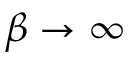Convert formula to latex. <formula><loc_0><loc_0><loc_500><loc_500>\beta \rightarrow \infty</formula> 